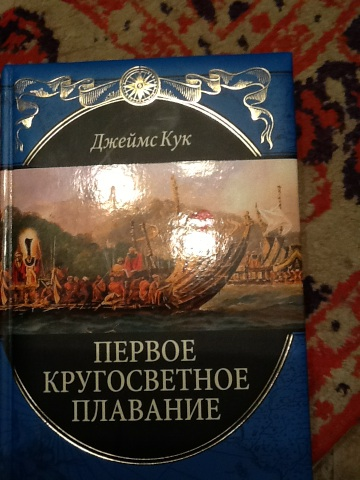What is the significance of this book? This book details the first circumnavigation of the world by James Cook, an historical journey that greatly contributed to geographical and cultural understanding in the 18th century. 